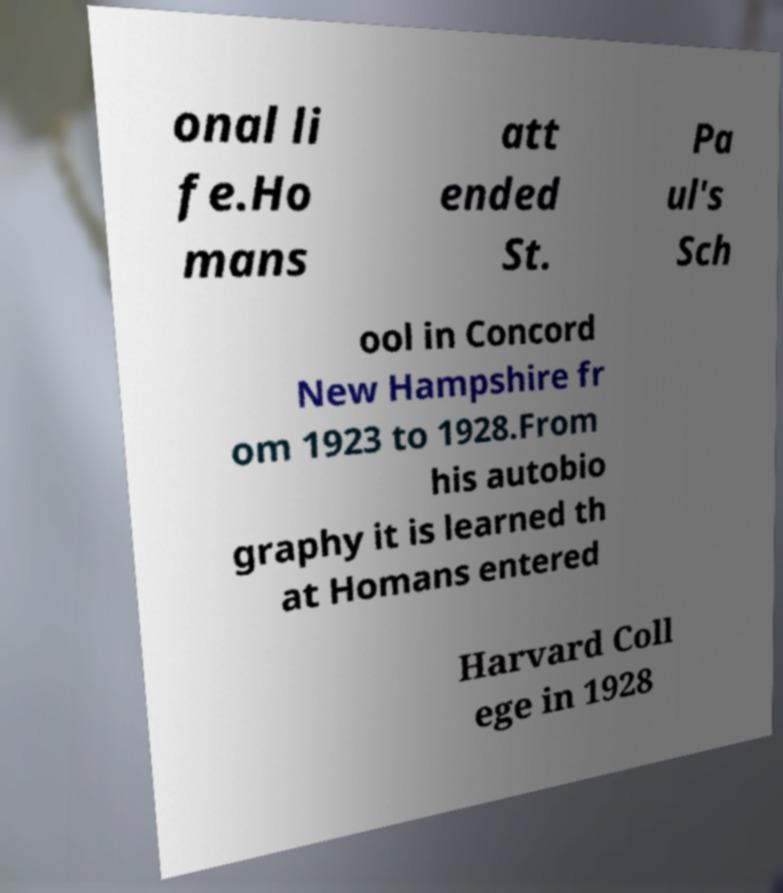There's text embedded in this image that I need extracted. Can you transcribe it verbatim? onal li fe.Ho mans att ended St. Pa ul's Sch ool in Concord New Hampshire fr om 1923 to 1928.From his autobio graphy it is learned th at Homans entered Harvard Coll ege in 1928 